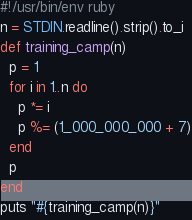Convert code to text. <code><loc_0><loc_0><loc_500><loc_500><_Ruby_>#!/usr/bin/env ruby
n = STDIN.readline().strip().to_i
def training_camp(n)
  p = 1
  for i in 1..n do
    p *= i
    p %= (1_000_000_000 + 7)
  end
  p
end
puts "#{training_camp(n)}"
</code> 